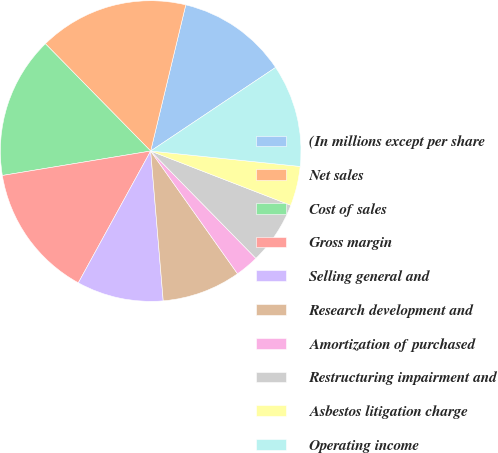Convert chart. <chart><loc_0><loc_0><loc_500><loc_500><pie_chart><fcel>(In millions except per share<fcel>Net sales<fcel>Cost of sales<fcel>Gross margin<fcel>Selling general and<fcel>Research development and<fcel>Amortization of purchased<fcel>Restructuring impairment and<fcel>Asbestos litigation charge<fcel>Operating income<nl><fcel>11.86%<fcel>16.1%<fcel>15.25%<fcel>14.41%<fcel>9.32%<fcel>8.47%<fcel>2.54%<fcel>6.78%<fcel>4.24%<fcel>11.02%<nl></chart> 